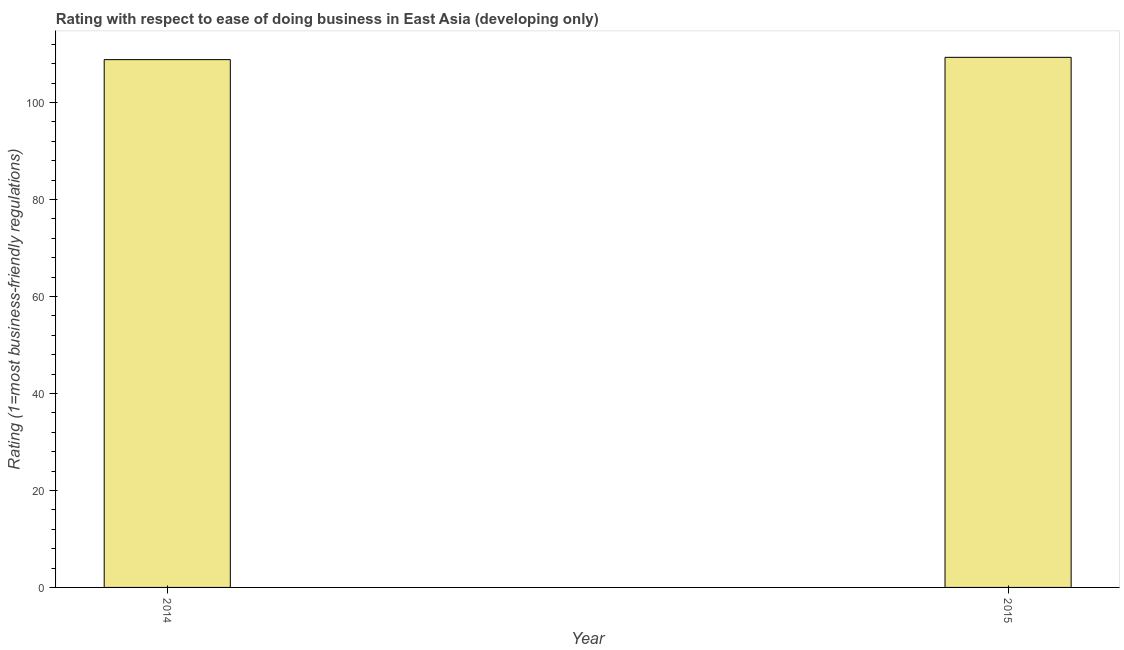Does the graph contain any zero values?
Provide a succinct answer. No. What is the title of the graph?
Your answer should be very brief. Rating with respect to ease of doing business in East Asia (developing only). What is the label or title of the Y-axis?
Your response must be concise. Rating (1=most business-friendly regulations). What is the ease of doing business index in 2014?
Offer a terse response. 108.86. Across all years, what is the maximum ease of doing business index?
Your response must be concise. 109.33. Across all years, what is the minimum ease of doing business index?
Your answer should be compact. 108.86. In which year was the ease of doing business index maximum?
Your response must be concise. 2015. What is the sum of the ease of doing business index?
Your answer should be compact. 218.19. What is the difference between the ease of doing business index in 2014 and 2015?
Keep it short and to the point. -0.48. What is the average ease of doing business index per year?
Your answer should be very brief. 109.09. What is the median ease of doing business index?
Make the answer very short. 109.1. In how many years, is the ease of doing business index greater than 68 ?
Provide a short and direct response. 2. What is the ratio of the ease of doing business index in 2014 to that in 2015?
Offer a very short reply. 1. Are all the bars in the graph horizontal?
Provide a succinct answer. No. How many years are there in the graph?
Keep it short and to the point. 2. What is the difference between two consecutive major ticks on the Y-axis?
Ensure brevity in your answer.  20. What is the Rating (1=most business-friendly regulations) of 2014?
Offer a very short reply. 108.86. What is the Rating (1=most business-friendly regulations) in 2015?
Provide a succinct answer. 109.33. What is the difference between the Rating (1=most business-friendly regulations) in 2014 and 2015?
Offer a very short reply. -0.48. 